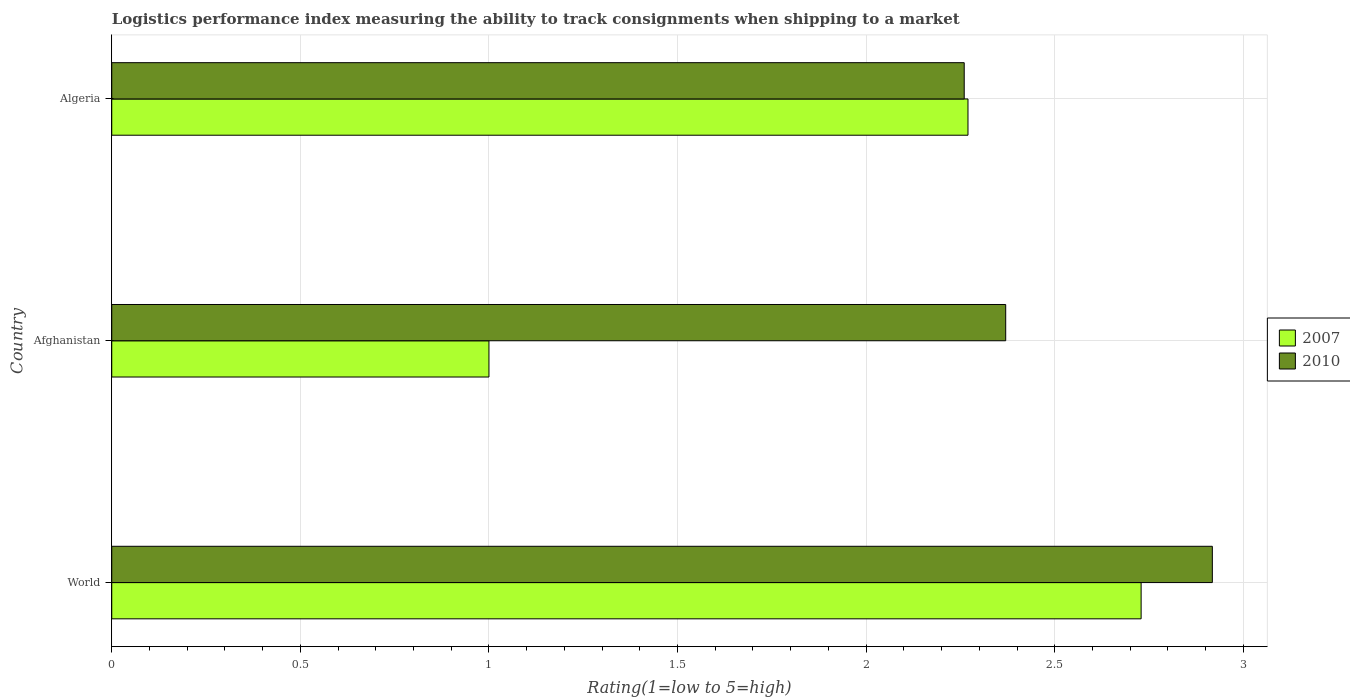Are the number of bars per tick equal to the number of legend labels?
Provide a short and direct response. Yes. Are the number of bars on each tick of the Y-axis equal?
Keep it short and to the point. Yes. How many bars are there on the 2nd tick from the top?
Provide a succinct answer. 2. What is the label of the 2nd group of bars from the top?
Make the answer very short. Afghanistan. What is the Logistic performance index in 2010 in World?
Make the answer very short. 2.92. Across all countries, what is the maximum Logistic performance index in 2010?
Keep it short and to the point. 2.92. In which country was the Logistic performance index in 2010 minimum?
Ensure brevity in your answer.  Algeria. What is the total Logistic performance index in 2007 in the graph?
Offer a terse response. 6. What is the difference between the Logistic performance index in 2010 in Algeria and that in World?
Your answer should be compact. -0.66. What is the difference between the Logistic performance index in 2007 in Algeria and the Logistic performance index in 2010 in World?
Make the answer very short. -0.65. What is the average Logistic performance index in 2007 per country?
Keep it short and to the point. 2. What is the difference between the Logistic performance index in 2007 and Logistic performance index in 2010 in World?
Your answer should be compact. -0.19. In how many countries, is the Logistic performance index in 2007 greater than 0.30000000000000004 ?
Provide a short and direct response. 3. What is the ratio of the Logistic performance index in 2010 in Algeria to that in World?
Offer a terse response. 0.77. Is the difference between the Logistic performance index in 2007 in Afghanistan and Algeria greater than the difference between the Logistic performance index in 2010 in Afghanistan and Algeria?
Ensure brevity in your answer.  No. What is the difference between the highest and the second highest Logistic performance index in 2007?
Provide a short and direct response. 0.46. What is the difference between the highest and the lowest Logistic performance index in 2010?
Your answer should be very brief. 0.66. In how many countries, is the Logistic performance index in 2007 greater than the average Logistic performance index in 2007 taken over all countries?
Make the answer very short. 2. Is the sum of the Logistic performance index in 2010 in Afghanistan and World greater than the maximum Logistic performance index in 2007 across all countries?
Ensure brevity in your answer.  Yes. What does the 2nd bar from the top in Algeria represents?
Give a very brief answer. 2007. What does the 2nd bar from the bottom in Afghanistan represents?
Your answer should be very brief. 2010. What is the difference between two consecutive major ticks on the X-axis?
Provide a short and direct response. 0.5. Are the values on the major ticks of X-axis written in scientific E-notation?
Provide a short and direct response. No. Does the graph contain any zero values?
Your answer should be compact. No. How many legend labels are there?
Your answer should be compact. 2. What is the title of the graph?
Offer a very short reply. Logistics performance index measuring the ability to track consignments when shipping to a market. What is the label or title of the X-axis?
Offer a terse response. Rating(1=low to 5=high). What is the label or title of the Y-axis?
Make the answer very short. Country. What is the Rating(1=low to 5=high) in 2007 in World?
Provide a short and direct response. 2.73. What is the Rating(1=low to 5=high) of 2010 in World?
Provide a succinct answer. 2.92. What is the Rating(1=low to 5=high) of 2010 in Afghanistan?
Offer a very short reply. 2.37. What is the Rating(1=low to 5=high) in 2007 in Algeria?
Offer a terse response. 2.27. What is the Rating(1=low to 5=high) of 2010 in Algeria?
Offer a very short reply. 2.26. Across all countries, what is the maximum Rating(1=low to 5=high) of 2007?
Ensure brevity in your answer.  2.73. Across all countries, what is the maximum Rating(1=low to 5=high) in 2010?
Offer a very short reply. 2.92. Across all countries, what is the minimum Rating(1=low to 5=high) of 2010?
Your answer should be compact. 2.26. What is the total Rating(1=low to 5=high) in 2007 in the graph?
Offer a very short reply. 6. What is the total Rating(1=low to 5=high) of 2010 in the graph?
Your response must be concise. 7.55. What is the difference between the Rating(1=low to 5=high) of 2007 in World and that in Afghanistan?
Offer a terse response. 1.73. What is the difference between the Rating(1=low to 5=high) in 2010 in World and that in Afghanistan?
Provide a succinct answer. 0.55. What is the difference between the Rating(1=low to 5=high) of 2007 in World and that in Algeria?
Your answer should be very brief. 0.46. What is the difference between the Rating(1=low to 5=high) of 2010 in World and that in Algeria?
Give a very brief answer. 0.66. What is the difference between the Rating(1=low to 5=high) in 2007 in Afghanistan and that in Algeria?
Provide a succinct answer. -1.27. What is the difference between the Rating(1=low to 5=high) of 2010 in Afghanistan and that in Algeria?
Offer a terse response. 0.11. What is the difference between the Rating(1=low to 5=high) of 2007 in World and the Rating(1=low to 5=high) of 2010 in Afghanistan?
Make the answer very short. 0.36. What is the difference between the Rating(1=low to 5=high) of 2007 in World and the Rating(1=low to 5=high) of 2010 in Algeria?
Offer a very short reply. 0.47. What is the difference between the Rating(1=low to 5=high) of 2007 in Afghanistan and the Rating(1=low to 5=high) of 2010 in Algeria?
Keep it short and to the point. -1.26. What is the average Rating(1=low to 5=high) in 2007 per country?
Give a very brief answer. 2. What is the average Rating(1=low to 5=high) of 2010 per country?
Offer a terse response. 2.52. What is the difference between the Rating(1=low to 5=high) of 2007 and Rating(1=low to 5=high) of 2010 in World?
Offer a very short reply. -0.19. What is the difference between the Rating(1=low to 5=high) of 2007 and Rating(1=low to 5=high) of 2010 in Afghanistan?
Offer a terse response. -1.37. What is the ratio of the Rating(1=low to 5=high) in 2007 in World to that in Afghanistan?
Provide a succinct answer. 2.73. What is the ratio of the Rating(1=low to 5=high) of 2010 in World to that in Afghanistan?
Offer a very short reply. 1.23. What is the ratio of the Rating(1=low to 5=high) of 2007 in World to that in Algeria?
Offer a terse response. 1.2. What is the ratio of the Rating(1=low to 5=high) in 2010 in World to that in Algeria?
Your answer should be compact. 1.29. What is the ratio of the Rating(1=low to 5=high) of 2007 in Afghanistan to that in Algeria?
Provide a succinct answer. 0.44. What is the ratio of the Rating(1=low to 5=high) of 2010 in Afghanistan to that in Algeria?
Give a very brief answer. 1.05. What is the difference between the highest and the second highest Rating(1=low to 5=high) of 2007?
Keep it short and to the point. 0.46. What is the difference between the highest and the second highest Rating(1=low to 5=high) of 2010?
Make the answer very short. 0.55. What is the difference between the highest and the lowest Rating(1=low to 5=high) in 2007?
Your answer should be very brief. 1.73. What is the difference between the highest and the lowest Rating(1=low to 5=high) of 2010?
Your answer should be very brief. 0.66. 